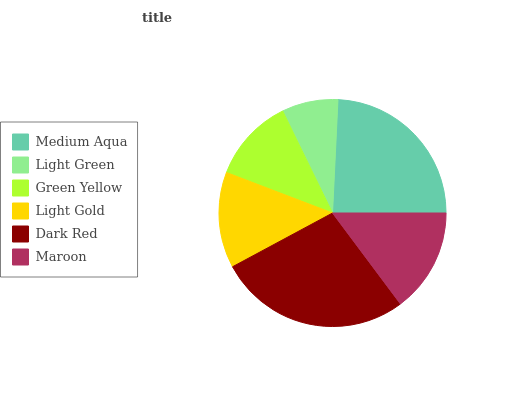Is Light Green the minimum?
Answer yes or no. Yes. Is Dark Red the maximum?
Answer yes or no. Yes. Is Green Yellow the minimum?
Answer yes or no. No. Is Green Yellow the maximum?
Answer yes or no. No. Is Green Yellow greater than Light Green?
Answer yes or no. Yes. Is Light Green less than Green Yellow?
Answer yes or no. Yes. Is Light Green greater than Green Yellow?
Answer yes or no. No. Is Green Yellow less than Light Green?
Answer yes or no. No. Is Maroon the high median?
Answer yes or no. Yes. Is Light Gold the low median?
Answer yes or no. Yes. Is Light Gold the high median?
Answer yes or no. No. Is Light Green the low median?
Answer yes or no. No. 